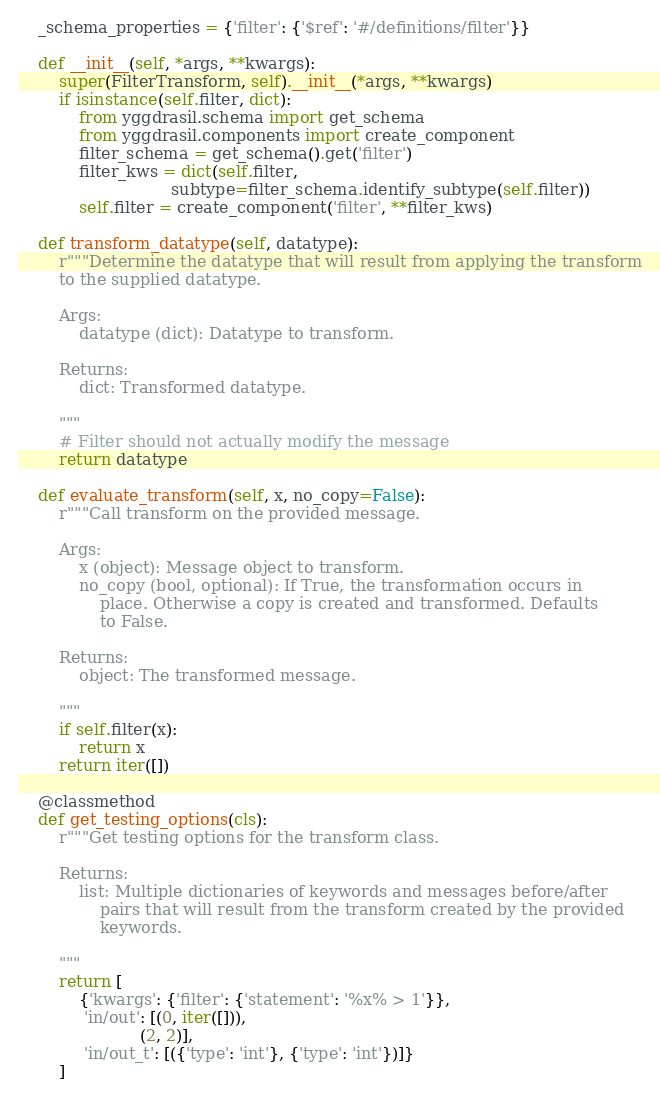Convert code to text. <code><loc_0><loc_0><loc_500><loc_500><_Python_>    _schema_properties = {'filter': {'$ref': '#/definitions/filter'}}

    def __init__(self, *args, **kwargs):
        super(FilterTransform, self).__init__(*args, **kwargs)
        if isinstance(self.filter, dict):
            from yggdrasil.schema import get_schema
            from yggdrasil.components import create_component
            filter_schema = get_schema().get('filter')
            filter_kws = dict(self.filter,
                              subtype=filter_schema.identify_subtype(self.filter))
            self.filter = create_component('filter', **filter_kws)
    
    def transform_datatype(self, datatype):
        r"""Determine the datatype that will result from applying the transform
        to the supplied datatype.

        Args:
            datatype (dict): Datatype to transform.

        Returns:
            dict: Transformed datatype.

        """
        # Filter should not actually modify the message
        return datatype

    def evaluate_transform(self, x, no_copy=False):
        r"""Call transform on the provided message.

        Args:
            x (object): Message object to transform.
            no_copy (bool, optional): If True, the transformation occurs in
                place. Otherwise a copy is created and transformed. Defaults
                to False.

        Returns:
            object: The transformed message.

        """
        if self.filter(x):
            return x
        return iter([])

    @classmethod
    def get_testing_options(cls):
        r"""Get testing options for the transform class.

        Returns:
            list: Multiple dictionaries of keywords and messages before/after
                pairs that will result from the transform created by the provided
                keywords.
        
        """
        return [
            {'kwargs': {'filter': {'statement': '%x% > 1'}},
             'in/out': [(0, iter([])),
                        (2, 2)],
             'in/out_t': [({'type': 'int'}, {'type': 'int'})]}
        ]
</code> 